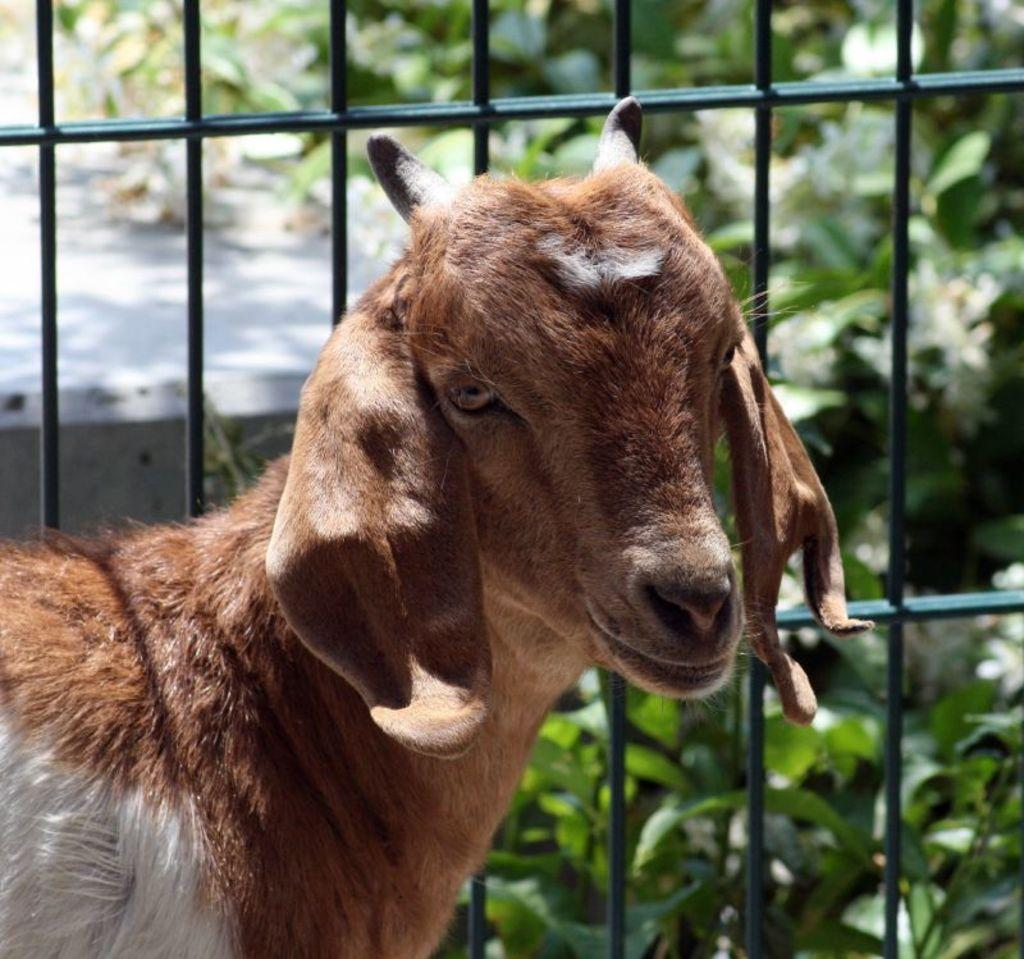What type of animal is present in the image? There is a goat in the image. What can be seen in the background of the image? There is a grill and plants in the background of the image. What reason does the actor give for wearing a sweater in the image? There is no actor or sweater present in the image, so it is not possible to determine the reason for wearing a sweater. 